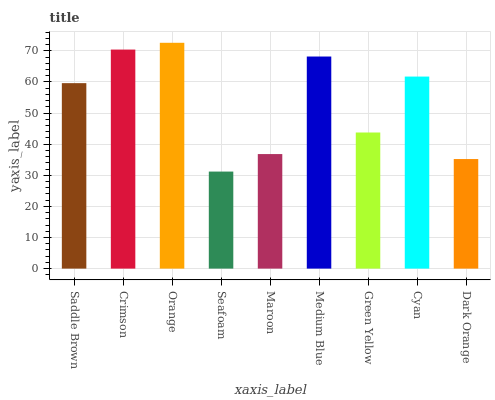Is Seafoam the minimum?
Answer yes or no. Yes. Is Orange the maximum?
Answer yes or no. Yes. Is Crimson the minimum?
Answer yes or no. No. Is Crimson the maximum?
Answer yes or no. No. Is Crimson greater than Saddle Brown?
Answer yes or no. Yes. Is Saddle Brown less than Crimson?
Answer yes or no. Yes. Is Saddle Brown greater than Crimson?
Answer yes or no. No. Is Crimson less than Saddle Brown?
Answer yes or no. No. Is Saddle Brown the high median?
Answer yes or no. Yes. Is Saddle Brown the low median?
Answer yes or no. Yes. Is Medium Blue the high median?
Answer yes or no. No. Is Medium Blue the low median?
Answer yes or no. No. 